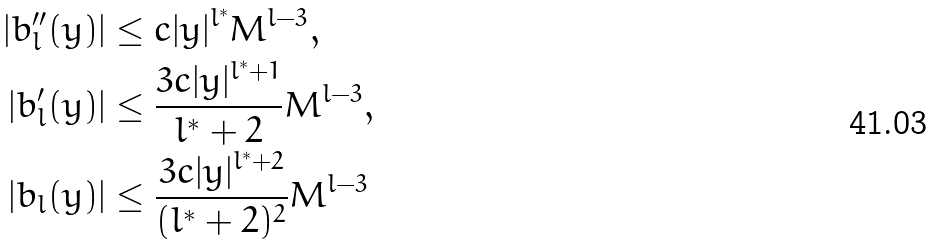Convert formula to latex. <formula><loc_0><loc_0><loc_500><loc_500>| b ^ { \prime \prime } _ { l } ( y ) | & \leq c | y | ^ { l ^ { * } } M ^ { l - 3 } , \\ | b ^ { \prime } _ { l } ( y ) | & \leq \frac { 3 c | y | ^ { l ^ { * } + 1 } } { l ^ { * } + 2 } M ^ { l - 3 } , \\ | b _ { l } ( y ) | & \leq \frac { 3 c | y | ^ { l ^ { * } + 2 } } { ( l ^ { * } + 2 ) ^ { 2 } } M ^ { l - 3 }</formula> 